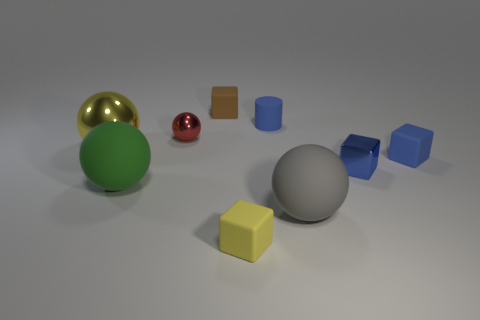Subtract all tiny metallic cubes. How many cubes are left? 3 Subtract all blue blocks. How many blocks are left? 2 Add 3 tiny yellow matte blocks. How many tiny yellow matte blocks are left? 4 Add 5 brown matte things. How many brown matte things exist? 6 Subtract 0 red cubes. How many objects are left? 9 Subtract all cylinders. How many objects are left? 8 Subtract 1 spheres. How many spheres are left? 3 Subtract all red blocks. Subtract all purple balls. How many blocks are left? 4 Subtract all gray cylinders. How many purple spheres are left? 0 Subtract all tiny purple things. Subtract all big things. How many objects are left? 6 